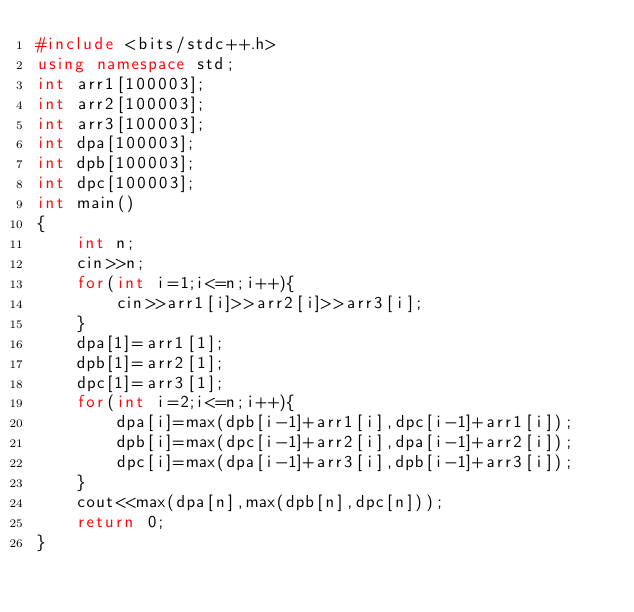Convert code to text. <code><loc_0><loc_0><loc_500><loc_500><_C++_>#include <bits/stdc++.h>
using namespace std;
int arr1[100003];
int arr2[100003];
int arr3[100003];
int dpa[100003];
int dpb[100003];
int dpc[100003];
int main()
{
    int n;
    cin>>n;
    for(int i=1;i<=n;i++){
        cin>>arr1[i]>>arr2[i]>>arr3[i];
    }
    dpa[1]=arr1[1];
    dpb[1]=arr2[1];
    dpc[1]=arr3[1];
    for(int i=2;i<=n;i++){
        dpa[i]=max(dpb[i-1]+arr1[i],dpc[i-1]+arr1[i]);
        dpb[i]=max(dpc[i-1]+arr2[i],dpa[i-1]+arr2[i]);
        dpc[i]=max(dpa[i-1]+arr3[i],dpb[i-1]+arr3[i]);
    }
    cout<<max(dpa[n],max(dpb[n],dpc[n]));
    return 0;
}
</code> 